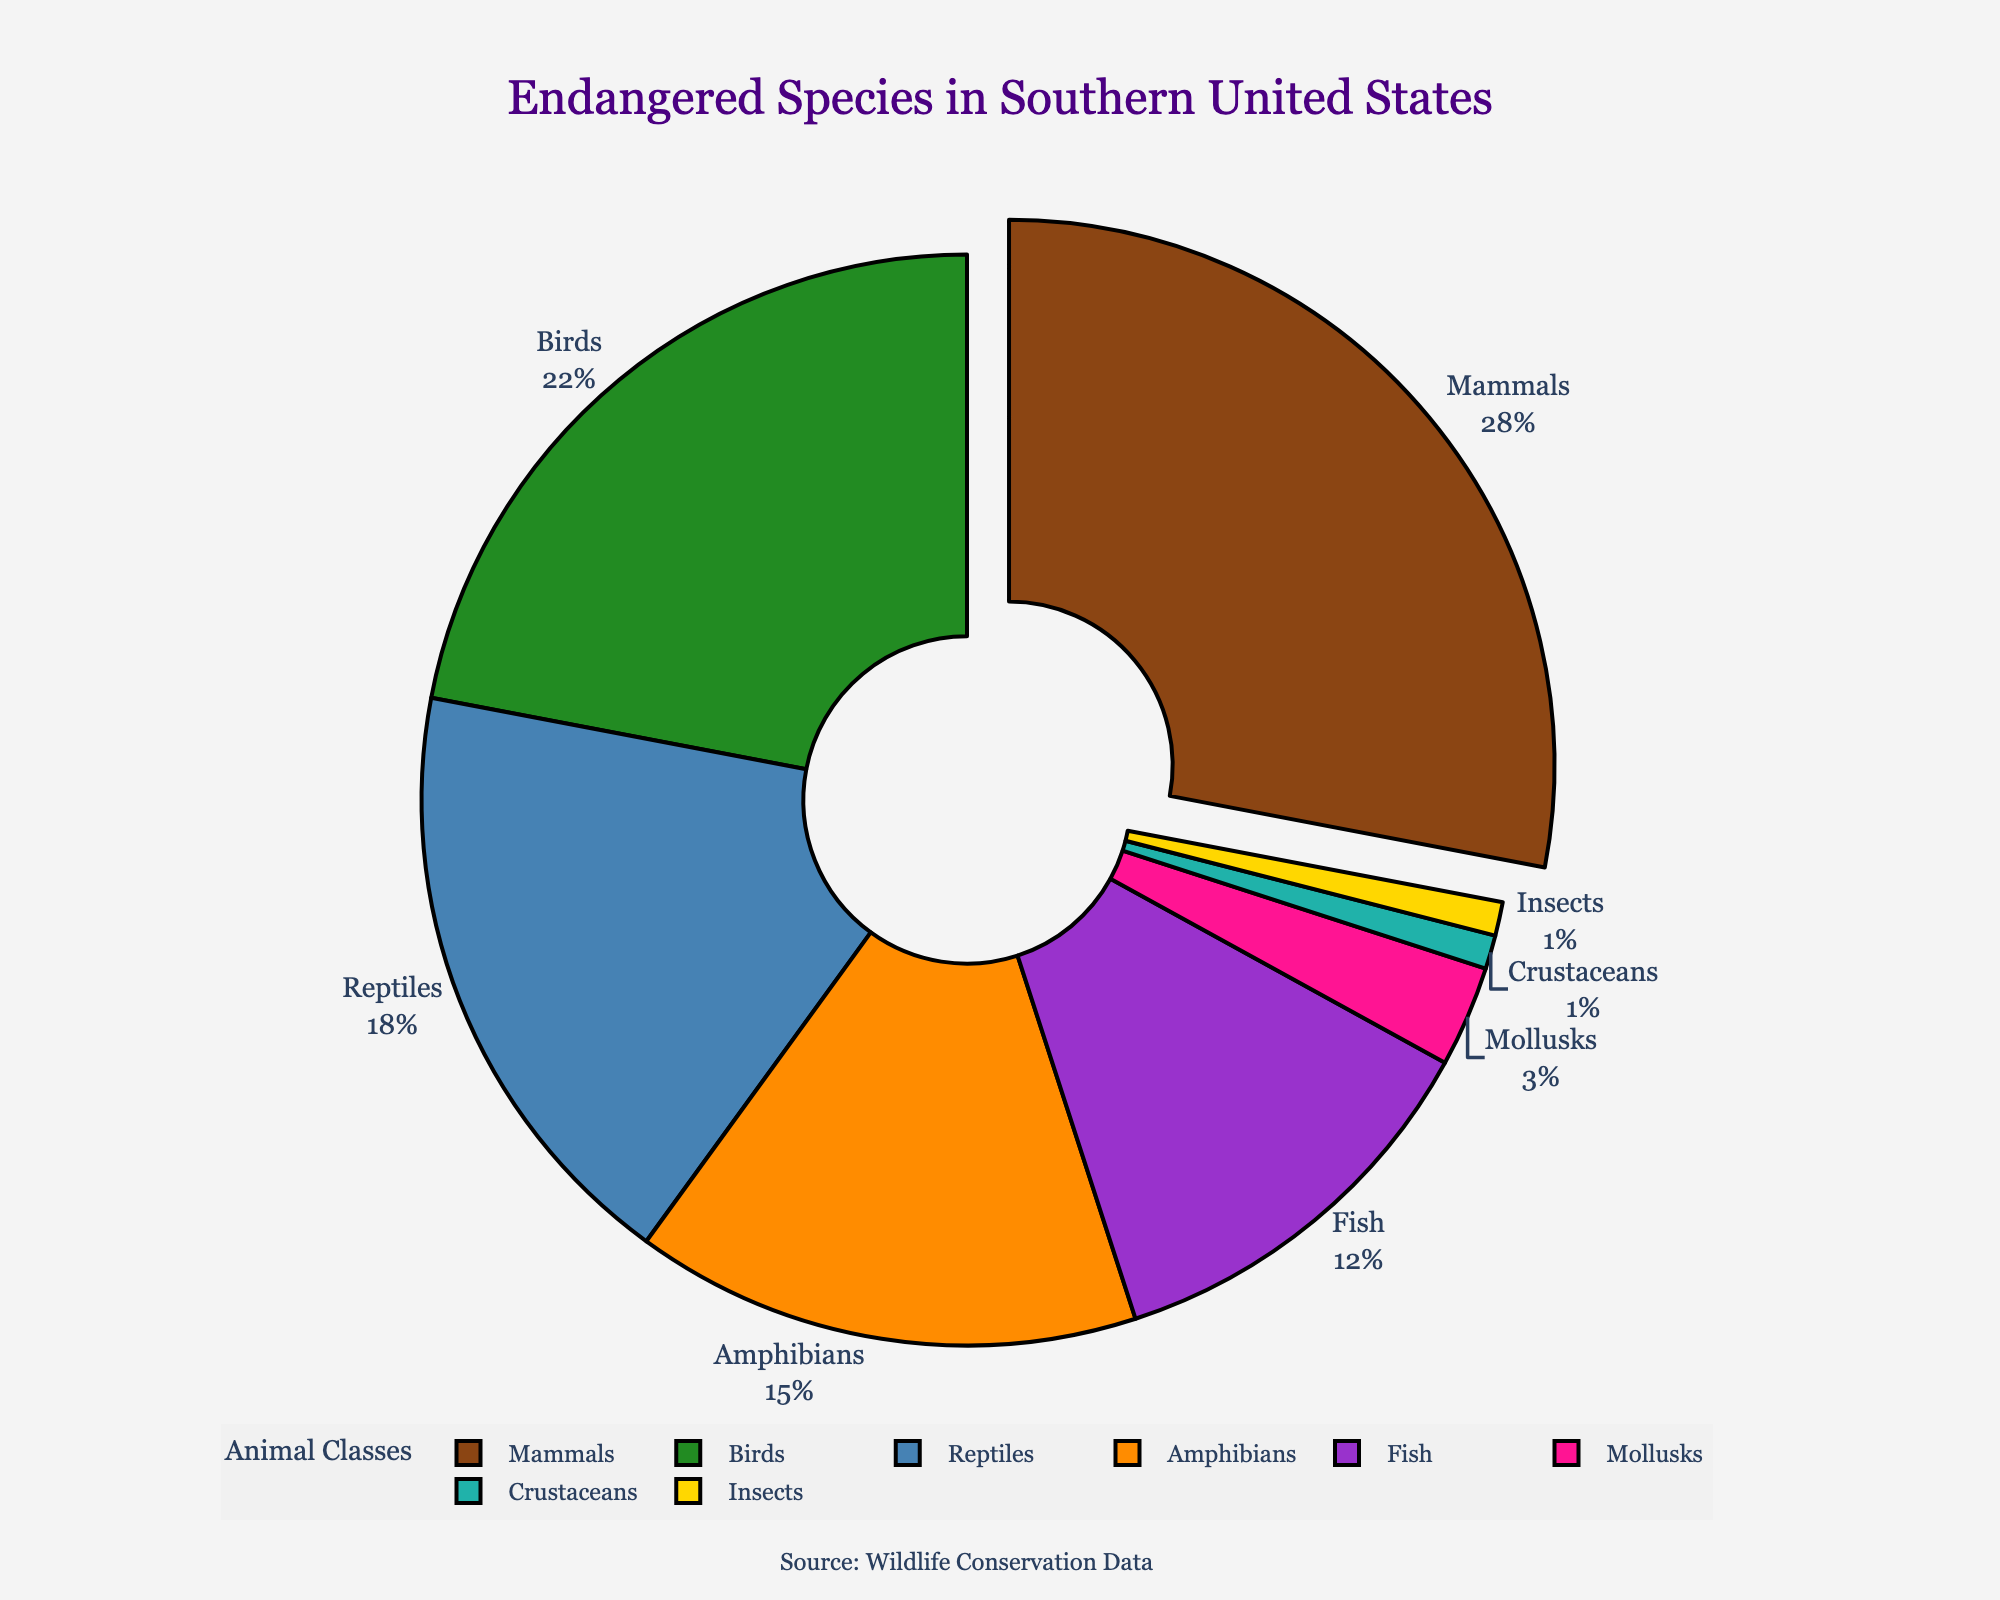Which animal class has the highest percentage of endangered species? The pie chart shows that mammals have the largest segment. The percentage for mammals is the highest among all classes.
Answer: Mammals How many animal classes have a percentage of endangered species greater than 15%? The pie chart indicates that mammals (28%), birds (22%), and reptiles (18%) have percentages greater than 15%. These are three classes.
Answer: 3 What is the combined percentage of endangered species for fish, mollusks, crustaceans, and insects? By adding the percentages of fish (12%), mollusks (3%), crustaceans (1%), and insects (1%), the sum is 12 + 3 + 1 + 1 = 17%.
Answer: 17% Which two animal classes have the smallest percentages of endangered species? The pie chart shows that crustaceans (1%) and insects (1%) have the smallest segments.
Answer: Crustaceans and Insects Which color represents the reptile class in the pie chart? The pie chart utilizes different colors, and reptiles are represented by a section colored in blue.
Answer: Blue What is the difference in percentage between mammal and bird endangered species? The pie chart shows mammals at 28% and birds at 22%. The difference is 28% - 22% = 6%.
Answer: 6% Which class has nearly half the percentage of amphibians? Amphibians are at 15%. Half of this is 7.5%. This is closest to the 12% of fish.
Answer: Fish Are insects and crustaceans represented by the same percentage? The pie chart shows both insects and crustaceans with a percentage of 1%. Therefore, they have the same percentage.
Answer: Yes What is the average percentage of endangered species across all animal classes shown? To find the average, sum all percentages: 28 + 22 + 18 + 15 + 12 + 3 + 1 + 1 = 100%. Since there are 8 classes, the average is 100/8 = 12.5%.
Answer: 12.5% If birds were to increase by 10%, what would their new percentage be and would it exceed mammals? Currently, birds are at 22%. An increase of 10% makes it 22% + 10% = 32%. Since mammals are at 28%, 32% for birds would exceed mammals.
Answer: Yes, 32% 